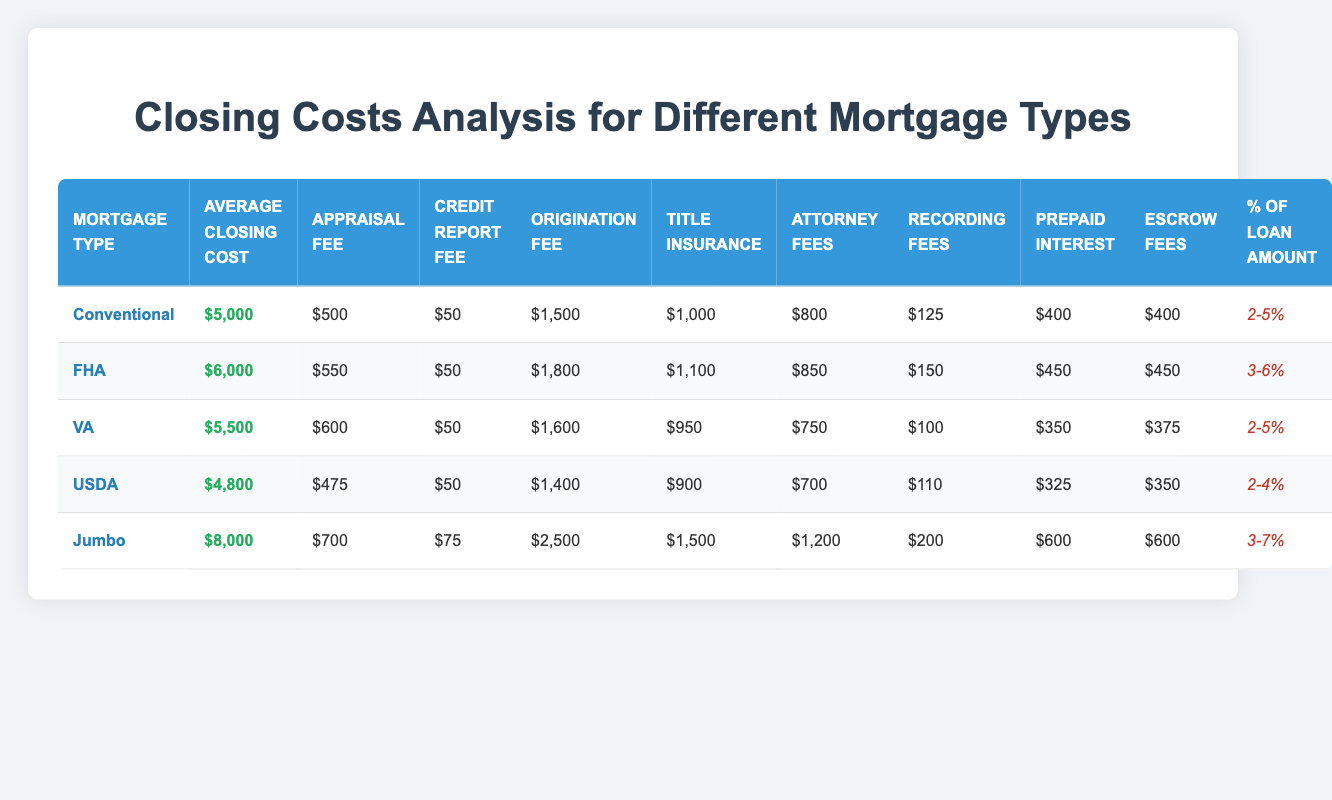What is the average closing cost for a Jumbo mortgage? According to the table, the average closing cost for a Jumbo mortgage is listed as $8,000.
Answer: $8,000 What is the highest origination fee among the mortgage types? From the table, the origination fees are as follows: Conventional ($1,500), FHA ($1,800), VA ($1,600), USDA ($1,400), Jumbo ($2,500). The highest is $2,500 for the Jumbo mortgage.
Answer: $2,500 Is the appraisal fee for FHA mortgages higher than that for USDA mortgages? The appraisal fee for FHA is $550, while for USDA it is $475. Since $550 is greater than $475, the statement is true.
Answer: Yes What are the average closing costs for mortgage types with a closing cost percentage of 2-5%? The mortgage types with a closing cost percentage of 2-5% are Conventional ($5,000) and VA ($5,500). To find the average, we sum these: $5,000 + $5,500 = $10,500, then divide by 2, giving us an average of $5,250.
Answer: $5,250 Which mortgage type has the lowest average closing cost? The table shows that USDA has the lowest average closing cost at $4,800, compared to all other mortgage types listed.
Answer: $4,800 Do any mortgage types have a credit report fee other than $50? The credit report fee is the same across different types, with all but the Jumbo mortgage showing $50. Jumbo has a credit report fee of $75. Therefore, there is at least one type (Jumbo) that exceeds $50.
Answer: Yes What is the total amount of escrow fees for FHA and VA combined? From the table, FHA escrow fees amount to $450, and VA escrow fees are $375. When added together: $450 + $375 = $825.
Answer: $825 What is the difference in average closing costs between FHA and USDA mortgages? FHA has an average closing cost of $6,000 and USDA has $4,800. The difference is calculated as $6,000 - $4,800 = $1,200.
Answer: $1,200 How many mortgage types have an appraisal fee of $600 or more? Looking through the appraisal fees, we find that FHA ($550), VA ($600), and Jumbo ($700) surpass or meet $600. In total, three mortgage types have appraisal fees of $600 or more.
Answer: 3 